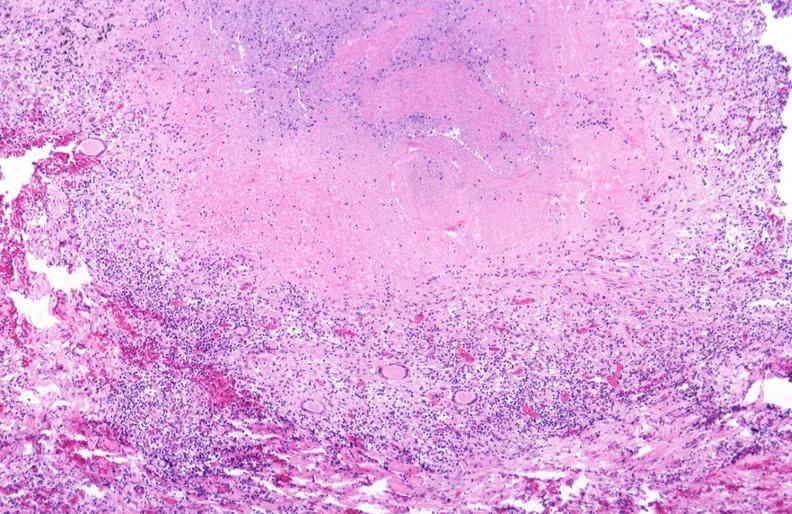does peritoneum show lung, mycobacterium tuberculosis, granulomas and giant cells?
Answer the question using a single word or phrase. No 